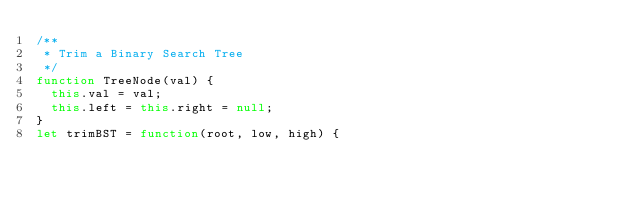<code> <loc_0><loc_0><loc_500><loc_500><_JavaScript_>/**
 * Trim a Binary Search Tree
 */
function TreeNode(val) {
  this.val = val;
  this.left = this.right = null;
}
let trimBST = function(root, low, high) {</code> 